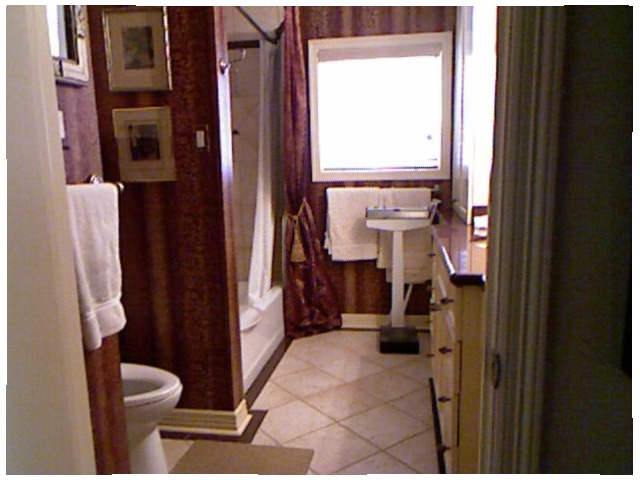<image>
Is there a toilet in front of the window? Yes. The toilet is positioned in front of the window, appearing closer to the camera viewpoint. Is the towel behind the window? No. The towel is not behind the window. From this viewpoint, the towel appears to be positioned elsewhere in the scene. 